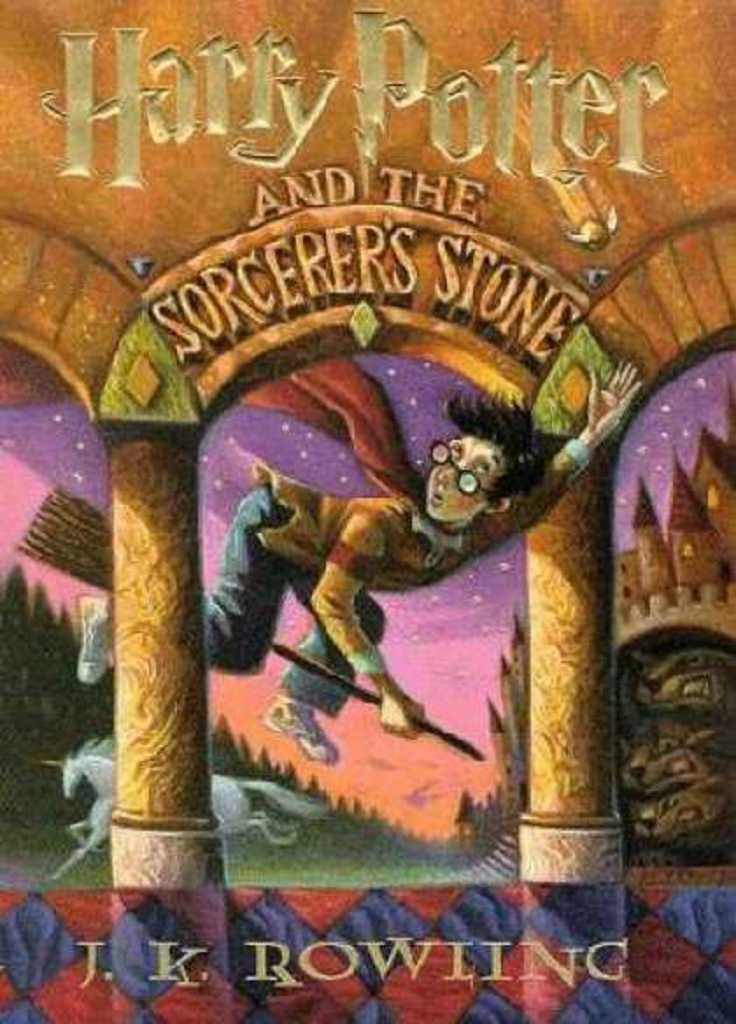<image>
Render a clear and concise summary of the photo. The cover of Harry Potter and the Sorcerers Stone. 